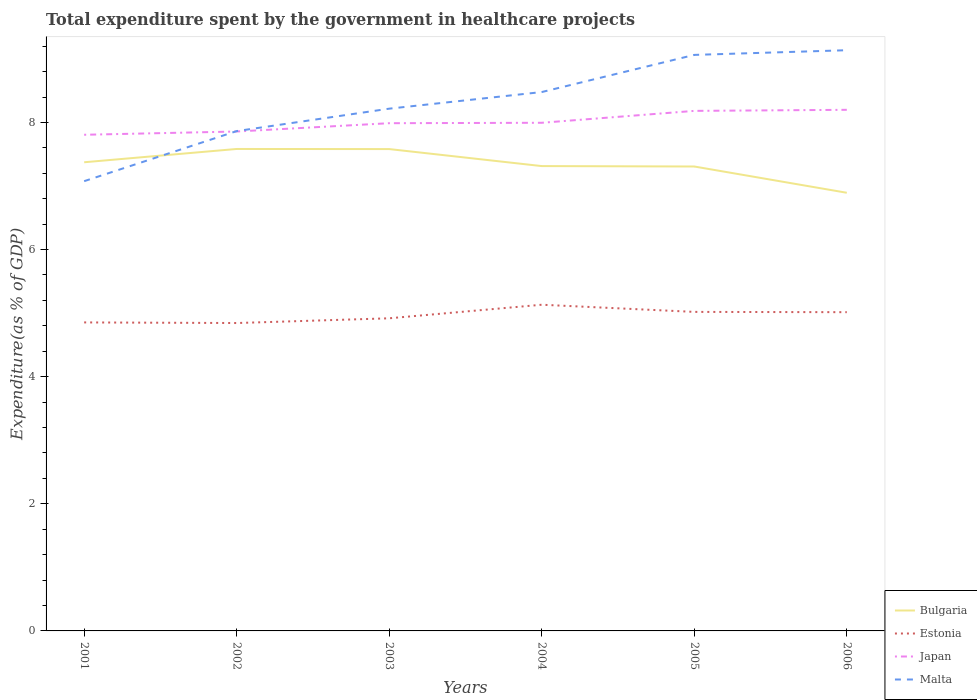How many different coloured lines are there?
Offer a very short reply. 4. Does the line corresponding to Bulgaria intersect with the line corresponding to Malta?
Your response must be concise. Yes. Across all years, what is the maximum total expenditure spent by the government in healthcare projects in Estonia?
Keep it short and to the point. 4.84. In which year was the total expenditure spent by the government in healthcare projects in Japan maximum?
Make the answer very short. 2001. What is the total total expenditure spent by the government in healthcare projects in Estonia in the graph?
Give a very brief answer. 0.01. What is the difference between the highest and the second highest total expenditure spent by the government in healthcare projects in Malta?
Make the answer very short. 2.06. What is the difference between the highest and the lowest total expenditure spent by the government in healthcare projects in Estonia?
Your response must be concise. 3. How many lines are there?
Ensure brevity in your answer.  4. How many legend labels are there?
Offer a very short reply. 4. What is the title of the graph?
Offer a terse response. Total expenditure spent by the government in healthcare projects. What is the label or title of the X-axis?
Offer a very short reply. Years. What is the label or title of the Y-axis?
Your response must be concise. Expenditure(as % of GDP). What is the Expenditure(as % of GDP) in Bulgaria in 2001?
Provide a succinct answer. 7.37. What is the Expenditure(as % of GDP) in Estonia in 2001?
Your response must be concise. 4.85. What is the Expenditure(as % of GDP) of Japan in 2001?
Provide a succinct answer. 7.81. What is the Expenditure(as % of GDP) in Malta in 2001?
Ensure brevity in your answer.  7.08. What is the Expenditure(as % of GDP) in Bulgaria in 2002?
Ensure brevity in your answer.  7.58. What is the Expenditure(as % of GDP) of Estonia in 2002?
Make the answer very short. 4.84. What is the Expenditure(as % of GDP) in Japan in 2002?
Provide a short and direct response. 7.86. What is the Expenditure(as % of GDP) in Malta in 2002?
Your response must be concise. 7.86. What is the Expenditure(as % of GDP) in Bulgaria in 2003?
Ensure brevity in your answer.  7.58. What is the Expenditure(as % of GDP) in Estonia in 2003?
Your answer should be very brief. 4.92. What is the Expenditure(as % of GDP) of Japan in 2003?
Keep it short and to the point. 7.99. What is the Expenditure(as % of GDP) in Malta in 2003?
Provide a short and direct response. 8.22. What is the Expenditure(as % of GDP) in Bulgaria in 2004?
Offer a terse response. 7.31. What is the Expenditure(as % of GDP) in Estonia in 2004?
Your answer should be compact. 5.13. What is the Expenditure(as % of GDP) of Japan in 2004?
Offer a terse response. 7.99. What is the Expenditure(as % of GDP) of Malta in 2004?
Provide a succinct answer. 8.48. What is the Expenditure(as % of GDP) in Bulgaria in 2005?
Your response must be concise. 7.31. What is the Expenditure(as % of GDP) of Estonia in 2005?
Offer a very short reply. 5.02. What is the Expenditure(as % of GDP) in Japan in 2005?
Your answer should be compact. 8.18. What is the Expenditure(as % of GDP) in Malta in 2005?
Offer a very short reply. 9.06. What is the Expenditure(as % of GDP) in Bulgaria in 2006?
Your answer should be compact. 6.89. What is the Expenditure(as % of GDP) in Estonia in 2006?
Your answer should be compact. 5.01. What is the Expenditure(as % of GDP) in Japan in 2006?
Provide a short and direct response. 8.2. What is the Expenditure(as % of GDP) in Malta in 2006?
Your answer should be compact. 9.14. Across all years, what is the maximum Expenditure(as % of GDP) in Bulgaria?
Your answer should be compact. 7.58. Across all years, what is the maximum Expenditure(as % of GDP) of Estonia?
Provide a succinct answer. 5.13. Across all years, what is the maximum Expenditure(as % of GDP) in Japan?
Provide a succinct answer. 8.2. Across all years, what is the maximum Expenditure(as % of GDP) in Malta?
Offer a very short reply. 9.14. Across all years, what is the minimum Expenditure(as % of GDP) in Bulgaria?
Provide a succinct answer. 6.89. Across all years, what is the minimum Expenditure(as % of GDP) in Estonia?
Your response must be concise. 4.84. Across all years, what is the minimum Expenditure(as % of GDP) of Japan?
Ensure brevity in your answer.  7.81. Across all years, what is the minimum Expenditure(as % of GDP) in Malta?
Your answer should be very brief. 7.08. What is the total Expenditure(as % of GDP) in Bulgaria in the graph?
Provide a short and direct response. 44.05. What is the total Expenditure(as % of GDP) in Estonia in the graph?
Offer a very short reply. 29.78. What is the total Expenditure(as % of GDP) of Japan in the graph?
Give a very brief answer. 48.03. What is the total Expenditure(as % of GDP) of Malta in the graph?
Provide a succinct answer. 49.83. What is the difference between the Expenditure(as % of GDP) of Bulgaria in 2001 and that in 2002?
Your answer should be compact. -0.21. What is the difference between the Expenditure(as % of GDP) in Estonia in 2001 and that in 2002?
Make the answer very short. 0.01. What is the difference between the Expenditure(as % of GDP) of Japan in 2001 and that in 2002?
Offer a terse response. -0.05. What is the difference between the Expenditure(as % of GDP) of Malta in 2001 and that in 2002?
Your answer should be compact. -0.79. What is the difference between the Expenditure(as % of GDP) of Bulgaria in 2001 and that in 2003?
Your answer should be very brief. -0.21. What is the difference between the Expenditure(as % of GDP) in Estonia in 2001 and that in 2003?
Ensure brevity in your answer.  -0.06. What is the difference between the Expenditure(as % of GDP) in Japan in 2001 and that in 2003?
Keep it short and to the point. -0.18. What is the difference between the Expenditure(as % of GDP) in Malta in 2001 and that in 2003?
Your answer should be very brief. -1.14. What is the difference between the Expenditure(as % of GDP) of Bulgaria in 2001 and that in 2004?
Keep it short and to the point. 0.06. What is the difference between the Expenditure(as % of GDP) in Estonia in 2001 and that in 2004?
Your answer should be very brief. -0.28. What is the difference between the Expenditure(as % of GDP) in Japan in 2001 and that in 2004?
Make the answer very short. -0.19. What is the difference between the Expenditure(as % of GDP) in Malta in 2001 and that in 2004?
Ensure brevity in your answer.  -1.4. What is the difference between the Expenditure(as % of GDP) of Bulgaria in 2001 and that in 2005?
Offer a very short reply. 0.07. What is the difference between the Expenditure(as % of GDP) in Estonia in 2001 and that in 2005?
Your answer should be very brief. -0.17. What is the difference between the Expenditure(as % of GDP) of Japan in 2001 and that in 2005?
Offer a very short reply. -0.38. What is the difference between the Expenditure(as % of GDP) of Malta in 2001 and that in 2005?
Ensure brevity in your answer.  -1.99. What is the difference between the Expenditure(as % of GDP) of Bulgaria in 2001 and that in 2006?
Provide a short and direct response. 0.48. What is the difference between the Expenditure(as % of GDP) in Estonia in 2001 and that in 2006?
Offer a terse response. -0.16. What is the difference between the Expenditure(as % of GDP) of Japan in 2001 and that in 2006?
Provide a short and direct response. -0.39. What is the difference between the Expenditure(as % of GDP) of Malta in 2001 and that in 2006?
Give a very brief answer. -2.06. What is the difference between the Expenditure(as % of GDP) in Bulgaria in 2002 and that in 2003?
Offer a terse response. 0. What is the difference between the Expenditure(as % of GDP) of Estonia in 2002 and that in 2003?
Offer a very short reply. -0.07. What is the difference between the Expenditure(as % of GDP) in Japan in 2002 and that in 2003?
Offer a terse response. -0.13. What is the difference between the Expenditure(as % of GDP) of Malta in 2002 and that in 2003?
Provide a short and direct response. -0.35. What is the difference between the Expenditure(as % of GDP) of Bulgaria in 2002 and that in 2004?
Offer a very short reply. 0.27. What is the difference between the Expenditure(as % of GDP) of Estonia in 2002 and that in 2004?
Offer a terse response. -0.29. What is the difference between the Expenditure(as % of GDP) in Japan in 2002 and that in 2004?
Your answer should be compact. -0.14. What is the difference between the Expenditure(as % of GDP) of Malta in 2002 and that in 2004?
Your answer should be very brief. -0.61. What is the difference between the Expenditure(as % of GDP) of Bulgaria in 2002 and that in 2005?
Offer a very short reply. 0.28. What is the difference between the Expenditure(as % of GDP) in Estonia in 2002 and that in 2005?
Ensure brevity in your answer.  -0.18. What is the difference between the Expenditure(as % of GDP) of Japan in 2002 and that in 2005?
Provide a short and direct response. -0.32. What is the difference between the Expenditure(as % of GDP) in Malta in 2002 and that in 2005?
Keep it short and to the point. -1.2. What is the difference between the Expenditure(as % of GDP) in Bulgaria in 2002 and that in 2006?
Offer a very short reply. 0.69. What is the difference between the Expenditure(as % of GDP) in Estonia in 2002 and that in 2006?
Your answer should be very brief. -0.17. What is the difference between the Expenditure(as % of GDP) of Japan in 2002 and that in 2006?
Offer a very short reply. -0.34. What is the difference between the Expenditure(as % of GDP) of Malta in 2002 and that in 2006?
Ensure brevity in your answer.  -1.27. What is the difference between the Expenditure(as % of GDP) of Bulgaria in 2003 and that in 2004?
Offer a very short reply. 0.27. What is the difference between the Expenditure(as % of GDP) in Estonia in 2003 and that in 2004?
Ensure brevity in your answer.  -0.21. What is the difference between the Expenditure(as % of GDP) in Japan in 2003 and that in 2004?
Offer a terse response. -0.01. What is the difference between the Expenditure(as % of GDP) in Malta in 2003 and that in 2004?
Give a very brief answer. -0.26. What is the difference between the Expenditure(as % of GDP) of Bulgaria in 2003 and that in 2005?
Give a very brief answer. 0.27. What is the difference between the Expenditure(as % of GDP) of Estonia in 2003 and that in 2005?
Ensure brevity in your answer.  -0.1. What is the difference between the Expenditure(as % of GDP) in Japan in 2003 and that in 2005?
Provide a succinct answer. -0.19. What is the difference between the Expenditure(as % of GDP) of Malta in 2003 and that in 2005?
Provide a succinct answer. -0.85. What is the difference between the Expenditure(as % of GDP) of Bulgaria in 2003 and that in 2006?
Offer a very short reply. 0.69. What is the difference between the Expenditure(as % of GDP) of Estonia in 2003 and that in 2006?
Make the answer very short. -0.1. What is the difference between the Expenditure(as % of GDP) of Japan in 2003 and that in 2006?
Provide a short and direct response. -0.21. What is the difference between the Expenditure(as % of GDP) of Malta in 2003 and that in 2006?
Offer a terse response. -0.92. What is the difference between the Expenditure(as % of GDP) of Bulgaria in 2004 and that in 2005?
Offer a very short reply. 0.01. What is the difference between the Expenditure(as % of GDP) in Estonia in 2004 and that in 2005?
Your answer should be very brief. 0.11. What is the difference between the Expenditure(as % of GDP) in Japan in 2004 and that in 2005?
Your answer should be compact. -0.19. What is the difference between the Expenditure(as % of GDP) in Malta in 2004 and that in 2005?
Your answer should be very brief. -0.58. What is the difference between the Expenditure(as % of GDP) of Bulgaria in 2004 and that in 2006?
Your answer should be compact. 0.42. What is the difference between the Expenditure(as % of GDP) in Estonia in 2004 and that in 2006?
Offer a very short reply. 0.12. What is the difference between the Expenditure(as % of GDP) in Japan in 2004 and that in 2006?
Offer a terse response. -0.2. What is the difference between the Expenditure(as % of GDP) of Malta in 2004 and that in 2006?
Your answer should be compact. -0.66. What is the difference between the Expenditure(as % of GDP) in Bulgaria in 2005 and that in 2006?
Keep it short and to the point. 0.41. What is the difference between the Expenditure(as % of GDP) of Estonia in 2005 and that in 2006?
Offer a terse response. 0. What is the difference between the Expenditure(as % of GDP) of Japan in 2005 and that in 2006?
Offer a terse response. -0.02. What is the difference between the Expenditure(as % of GDP) in Malta in 2005 and that in 2006?
Your answer should be compact. -0.07. What is the difference between the Expenditure(as % of GDP) of Bulgaria in 2001 and the Expenditure(as % of GDP) of Estonia in 2002?
Provide a short and direct response. 2.53. What is the difference between the Expenditure(as % of GDP) of Bulgaria in 2001 and the Expenditure(as % of GDP) of Japan in 2002?
Provide a succinct answer. -0.48. What is the difference between the Expenditure(as % of GDP) of Bulgaria in 2001 and the Expenditure(as % of GDP) of Malta in 2002?
Provide a succinct answer. -0.49. What is the difference between the Expenditure(as % of GDP) in Estonia in 2001 and the Expenditure(as % of GDP) in Japan in 2002?
Provide a succinct answer. -3. What is the difference between the Expenditure(as % of GDP) of Estonia in 2001 and the Expenditure(as % of GDP) of Malta in 2002?
Give a very brief answer. -3.01. What is the difference between the Expenditure(as % of GDP) in Japan in 2001 and the Expenditure(as % of GDP) in Malta in 2002?
Your response must be concise. -0.06. What is the difference between the Expenditure(as % of GDP) in Bulgaria in 2001 and the Expenditure(as % of GDP) in Estonia in 2003?
Your answer should be compact. 2.45. What is the difference between the Expenditure(as % of GDP) in Bulgaria in 2001 and the Expenditure(as % of GDP) in Japan in 2003?
Offer a very short reply. -0.61. What is the difference between the Expenditure(as % of GDP) of Bulgaria in 2001 and the Expenditure(as % of GDP) of Malta in 2003?
Provide a short and direct response. -0.84. What is the difference between the Expenditure(as % of GDP) in Estonia in 2001 and the Expenditure(as % of GDP) in Japan in 2003?
Provide a succinct answer. -3.13. What is the difference between the Expenditure(as % of GDP) of Estonia in 2001 and the Expenditure(as % of GDP) of Malta in 2003?
Provide a succinct answer. -3.36. What is the difference between the Expenditure(as % of GDP) of Japan in 2001 and the Expenditure(as % of GDP) of Malta in 2003?
Your answer should be very brief. -0.41. What is the difference between the Expenditure(as % of GDP) of Bulgaria in 2001 and the Expenditure(as % of GDP) of Estonia in 2004?
Give a very brief answer. 2.24. What is the difference between the Expenditure(as % of GDP) in Bulgaria in 2001 and the Expenditure(as % of GDP) in Japan in 2004?
Your answer should be compact. -0.62. What is the difference between the Expenditure(as % of GDP) in Bulgaria in 2001 and the Expenditure(as % of GDP) in Malta in 2004?
Offer a terse response. -1.1. What is the difference between the Expenditure(as % of GDP) of Estonia in 2001 and the Expenditure(as % of GDP) of Japan in 2004?
Give a very brief answer. -3.14. What is the difference between the Expenditure(as % of GDP) in Estonia in 2001 and the Expenditure(as % of GDP) in Malta in 2004?
Your answer should be very brief. -3.62. What is the difference between the Expenditure(as % of GDP) of Japan in 2001 and the Expenditure(as % of GDP) of Malta in 2004?
Provide a succinct answer. -0.67. What is the difference between the Expenditure(as % of GDP) in Bulgaria in 2001 and the Expenditure(as % of GDP) in Estonia in 2005?
Offer a very short reply. 2.35. What is the difference between the Expenditure(as % of GDP) in Bulgaria in 2001 and the Expenditure(as % of GDP) in Japan in 2005?
Provide a short and direct response. -0.81. What is the difference between the Expenditure(as % of GDP) of Bulgaria in 2001 and the Expenditure(as % of GDP) of Malta in 2005?
Ensure brevity in your answer.  -1.69. What is the difference between the Expenditure(as % of GDP) of Estonia in 2001 and the Expenditure(as % of GDP) of Japan in 2005?
Your answer should be compact. -3.33. What is the difference between the Expenditure(as % of GDP) of Estonia in 2001 and the Expenditure(as % of GDP) of Malta in 2005?
Provide a succinct answer. -4.21. What is the difference between the Expenditure(as % of GDP) of Japan in 2001 and the Expenditure(as % of GDP) of Malta in 2005?
Make the answer very short. -1.26. What is the difference between the Expenditure(as % of GDP) of Bulgaria in 2001 and the Expenditure(as % of GDP) of Estonia in 2006?
Offer a terse response. 2.36. What is the difference between the Expenditure(as % of GDP) in Bulgaria in 2001 and the Expenditure(as % of GDP) in Japan in 2006?
Ensure brevity in your answer.  -0.82. What is the difference between the Expenditure(as % of GDP) of Bulgaria in 2001 and the Expenditure(as % of GDP) of Malta in 2006?
Provide a succinct answer. -1.76. What is the difference between the Expenditure(as % of GDP) of Estonia in 2001 and the Expenditure(as % of GDP) of Japan in 2006?
Provide a short and direct response. -3.34. What is the difference between the Expenditure(as % of GDP) of Estonia in 2001 and the Expenditure(as % of GDP) of Malta in 2006?
Provide a short and direct response. -4.28. What is the difference between the Expenditure(as % of GDP) in Japan in 2001 and the Expenditure(as % of GDP) in Malta in 2006?
Your answer should be very brief. -1.33. What is the difference between the Expenditure(as % of GDP) in Bulgaria in 2002 and the Expenditure(as % of GDP) in Estonia in 2003?
Offer a terse response. 2.66. What is the difference between the Expenditure(as % of GDP) in Bulgaria in 2002 and the Expenditure(as % of GDP) in Japan in 2003?
Your response must be concise. -0.41. What is the difference between the Expenditure(as % of GDP) in Bulgaria in 2002 and the Expenditure(as % of GDP) in Malta in 2003?
Give a very brief answer. -0.63. What is the difference between the Expenditure(as % of GDP) of Estonia in 2002 and the Expenditure(as % of GDP) of Japan in 2003?
Make the answer very short. -3.14. What is the difference between the Expenditure(as % of GDP) of Estonia in 2002 and the Expenditure(as % of GDP) of Malta in 2003?
Your response must be concise. -3.37. What is the difference between the Expenditure(as % of GDP) of Japan in 2002 and the Expenditure(as % of GDP) of Malta in 2003?
Offer a terse response. -0.36. What is the difference between the Expenditure(as % of GDP) in Bulgaria in 2002 and the Expenditure(as % of GDP) in Estonia in 2004?
Keep it short and to the point. 2.45. What is the difference between the Expenditure(as % of GDP) of Bulgaria in 2002 and the Expenditure(as % of GDP) of Japan in 2004?
Keep it short and to the point. -0.41. What is the difference between the Expenditure(as % of GDP) in Bulgaria in 2002 and the Expenditure(as % of GDP) in Malta in 2004?
Offer a terse response. -0.9. What is the difference between the Expenditure(as % of GDP) of Estonia in 2002 and the Expenditure(as % of GDP) of Japan in 2004?
Provide a short and direct response. -3.15. What is the difference between the Expenditure(as % of GDP) in Estonia in 2002 and the Expenditure(as % of GDP) in Malta in 2004?
Offer a terse response. -3.63. What is the difference between the Expenditure(as % of GDP) in Japan in 2002 and the Expenditure(as % of GDP) in Malta in 2004?
Offer a very short reply. -0.62. What is the difference between the Expenditure(as % of GDP) of Bulgaria in 2002 and the Expenditure(as % of GDP) of Estonia in 2005?
Your answer should be compact. 2.56. What is the difference between the Expenditure(as % of GDP) in Bulgaria in 2002 and the Expenditure(as % of GDP) in Japan in 2005?
Offer a terse response. -0.6. What is the difference between the Expenditure(as % of GDP) in Bulgaria in 2002 and the Expenditure(as % of GDP) in Malta in 2005?
Your answer should be very brief. -1.48. What is the difference between the Expenditure(as % of GDP) of Estonia in 2002 and the Expenditure(as % of GDP) of Japan in 2005?
Your response must be concise. -3.34. What is the difference between the Expenditure(as % of GDP) of Estonia in 2002 and the Expenditure(as % of GDP) of Malta in 2005?
Keep it short and to the point. -4.22. What is the difference between the Expenditure(as % of GDP) in Japan in 2002 and the Expenditure(as % of GDP) in Malta in 2005?
Your answer should be compact. -1.21. What is the difference between the Expenditure(as % of GDP) in Bulgaria in 2002 and the Expenditure(as % of GDP) in Estonia in 2006?
Give a very brief answer. 2.57. What is the difference between the Expenditure(as % of GDP) of Bulgaria in 2002 and the Expenditure(as % of GDP) of Japan in 2006?
Offer a very short reply. -0.62. What is the difference between the Expenditure(as % of GDP) of Bulgaria in 2002 and the Expenditure(as % of GDP) of Malta in 2006?
Your response must be concise. -1.55. What is the difference between the Expenditure(as % of GDP) in Estonia in 2002 and the Expenditure(as % of GDP) in Japan in 2006?
Your answer should be compact. -3.35. What is the difference between the Expenditure(as % of GDP) in Estonia in 2002 and the Expenditure(as % of GDP) in Malta in 2006?
Offer a very short reply. -4.29. What is the difference between the Expenditure(as % of GDP) of Japan in 2002 and the Expenditure(as % of GDP) of Malta in 2006?
Give a very brief answer. -1.28. What is the difference between the Expenditure(as % of GDP) in Bulgaria in 2003 and the Expenditure(as % of GDP) in Estonia in 2004?
Offer a very short reply. 2.45. What is the difference between the Expenditure(as % of GDP) in Bulgaria in 2003 and the Expenditure(as % of GDP) in Japan in 2004?
Make the answer very short. -0.41. What is the difference between the Expenditure(as % of GDP) of Bulgaria in 2003 and the Expenditure(as % of GDP) of Malta in 2004?
Your answer should be very brief. -0.9. What is the difference between the Expenditure(as % of GDP) in Estonia in 2003 and the Expenditure(as % of GDP) in Japan in 2004?
Offer a very short reply. -3.08. What is the difference between the Expenditure(as % of GDP) of Estonia in 2003 and the Expenditure(as % of GDP) of Malta in 2004?
Provide a short and direct response. -3.56. What is the difference between the Expenditure(as % of GDP) in Japan in 2003 and the Expenditure(as % of GDP) in Malta in 2004?
Your response must be concise. -0.49. What is the difference between the Expenditure(as % of GDP) of Bulgaria in 2003 and the Expenditure(as % of GDP) of Estonia in 2005?
Your response must be concise. 2.56. What is the difference between the Expenditure(as % of GDP) of Bulgaria in 2003 and the Expenditure(as % of GDP) of Japan in 2005?
Ensure brevity in your answer.  -0.6. What is the difference between the Expenditure(as % of GDP) in Bulgaria in 2003 and the Expenditure(as % of GDP) in Malta in 2005?
Ensure brevity in your answer.  -1.48. What is the difference between the Expenditure(as % of GDP) of Estonia in 2003 and the Expenditure(as % of GDP) of Japan in 2005?
Give a very brief answer. -3.26. What is the difference between the Expenditure(as % of GDP) of Estonia in 2003 and the Expenditure(as % of GDP) of Malta in 2005?
Offer a terse response. -4.14. What is the difference between the Expenditure(as % of GDP) of Japan in 2003 and the Expenditure(as % of GDP) of Malta in 2005?
Ensure brevity in your answer.  -1.07. What is the difference between the Expenditure(as % of GDP) of Bulgaria in 2003 and the Expenditure(as % of GDP) of Estonia in 2006?
Ensure brevity in your answer.  2.57. What is the difference between the Expenditure(as % of GDP) in Bulgaria in 2003 and the Expenditure(as % of GDP) in Japan in 2006?
Give a very brief answer. -0.62. What is the difference between the Expenditure(as % of GDP) of Bulgaria in 2003 and the Expenditure(as % of GDP) of Malta in 2006?
Offer a very short reply. -1.56. What is the difference between the Expenditure(as % of GDP) in Estonia in 2003 and the Expenditure(as % of GDP) in Japan in 2006?
Give a very brief answer. -3.28. What is the difference between the Expenditure(as % of GDP) in Estonia in 2003 and the Expenditure(as % of GDP) in Malta in 2006?
Provide a short and direct response. -4.22. What is the difference between the Expenditure(as % of GDP) in Japan in 2003 and the Expenditure(as % of GDP) in Malta in 2006?
Provide a short and direct response. -1.15. What is the difference between the Expenditure(as % of GDP) in Bulgaria in 2004 and the Expenditure(as % of GDP) in Estonia in 2005?
Your answer should be very brief. 2.29. What is the difference between the Expenditure(as % of GDP) of Bulgaria in 2004 and the Expenditure(as % of GDP) of Japan in 2005?
Offer a terse response. -0.87. What is the difference between the Expenditure(as % of GDP) of Bulgaria in 2004 and the Expenditure(as % of GDP) of Malta in 2005?
Provide a short and direct response. -1.75. What is the difference between the Expenditure(as % of GDP) of Estonia in 2004 and the Expenditure(as % of GDP) of Japan in 2005?
Provide a short and direct response. -3.05. What is the difference between the Expenditure(as % of GDP) in Estonia in 2004 and the Expenditure(as % of GDP) in Malta in 2005?
Your answer should be very brief. -3.93. What is the difference between the Expenditure(as % of GDP) in Japan in 2004 and the Expenditure(as % of GDP) in Malta in 2005?
Give a very brief answer. -1.07. What is the difference between the Expenditure(as % of GDP) of Bulgaria in 2004 and the Expenditure(as % of GDP) of Estonia in 2006?
Offer a terse response. 2.3. What is the difference between the Expenditure(as % of GDP) of Bulgaria in 2004 and the Expenditure(as % of GDP) of Japan in 2006?
Provide a succinct answer. -0.89. What is the difference between the Expenditure(as % of GDP) in Bulgaria in 2004 and the Expenditure(as % of GDP) in Malta in 2006?
Provide a succinct answer. -1.82. What is the difference between the Expenditure(as % of GDP) in Estonia in 2004 and the Expenditure(as % of GDP) in Japan in 2006?
Give a very brief answer. -3.07. What is the difference between the Expenditure(as % of GDP) of Estonia in 2004 and the Expenditure(as % of GDP) of Malta in 2006?
Keep it short and to the point. -4. What is the difference between the Expenditure(as % of GDP) of Japan in 2004 and the Expenditure(as % of GDP) of Malta in 2006?
Your answer should be very brief. -1.14. What is the difference between the Expenditure(as % of GDP) in Bulgaria in 2005 and the Expenditure(as % of GDP) in Estonia in 2006?
Your answer should be compact. 2.29. What is the difference between the Expenditure(as % of GDP) of Bulgaria in 2005 and the Expenditure(as % of GDP) of Japan in 2006?
Offer a terse response. -0.89. What is the difference between the Expenditure(as % of GDP) in Bulgaria in 2005 and the Expenditure(as % of GDP) in Malta in 2006?
Your answer should be very brief. -1.83. What is the difference between the Expenditure(as % of GDP) in Estonia in 2005 and the Expenditure(as % of GDP) in Japan in 2006?
Provide a succinct answer. -3.18. What is the difference between the Expenditure(as % of GDP) in Estonia in 2005 and the Expenditure(as % of GDP) in Malta in 2006?
Offer a terse response. -4.12. What is the difference between the Expenditure(as % of GDP) in Japan in 2005 and the Expenditure(as % of GDP) in Malta in 2006?
Your answer should be compact. -0.95. What is the average Expenditure(as % of GDP) of Bulgaria per year?
Provide a short and direct response. 7.34. What is the average Expenditure(as % of GDP) in Estonia per year?
Offer a very short reply. 4.96. What is the average Expenditure(as % of GDP) in Japan per year?
Offer a very short reply. 8. What is the average Expenditure(as % of GDP) of Malta per year?
Give a very brief answer. 8.31. In the year 2001, what is the difference between the Expenditure(as % of GDP) in Bulgaria and Expenditure(as % of GDP) in Estonia?
Offer a very short reply. 2.52. In the year 2001, what is the difference between the Expenditure(as % of GDP) of Bulgaria and Expenditure(as % of GDP) of Japan?
Offer a very short reply. -0.43. In the year 2001, what is the difference between the Expenditure(as % of GDP) in Bulgaria and Expenditure(as % of GDP) in Malta?
Your response must be concise. 0.3. In the year 2001, what is the difference between the Expenditure(as % of GDP) of Estonia and Expenditure(as % of GDP) of Japan?
Make the answer very short. -2.95. In the year 2001, what is the difference between the Expenditure(as % of GDP) of Estonia and Expenditure(as % of GDP) of Malta?
Provide a succinct answer. -2.22. In the year 2001, what is the difference between the Expenditure(as % of GDP) in Japan and Expenditure(as % of GDP) in Malta?
Offer a terse response. 0.73. In the year 2002, what is the difference between the Expenditure(as % of GDP) of Bulgaria and Expenditure(as % of GDP) of Estonia?
Your answer should be compact. 2.74. In the year 2002, what is the difference between the Expenditure(as % of GDP) of Bulgaria and Expenditure(as % of GDP) of Japan?
Your answer should be compact. -0.27. In the year 2002, what is the difference between the Expenditure(as % of GDP) in Bulgaria and Expenditure(as % of GDP) in Malta?
Offer a very short reply. -0.28. In the year 2002, what is the difference between the Expenditure(as % of GDP) of Estonia and Expenditure(as % of GDP) of Japan?
Provide a short and direct response. -3.01. In the year 2002, what is the difference between the Expenditure(as % of GDP) of Estonia and Expenditure(as % of GDP) of Malta?
Your response must be concise. -3.02. In the year 2002, what is the difference between the Expenditure(as % of GDP) of Japan and Expenditure(as % of GDP) of Malta?
Ensure brevity in your answer.  -0.01. In the year 2003, what is the difference between the Expenditure(as % of GDP) of Bulgaria and Expenditure(as % of GDP) of Estonia?
Your answer should be very brief. 2.66. In the year 2003, what is the difference between the Expenditure(as % of GDP) in Bulgaria and Expenditure(as % of GDP) in Japan?
Keep it short and to the point. -0.41. In the year 2003, what is the difference between the Expenditure(as % of GDP) of Bulgaria and Expenditure(as % of GDP) of Malta?
Give a very brief answer. -0.64. In the year 2003, what is the difference between the Expenditure(as % of GDP) in Estonia and Expenditure(as % of GDP) in Japan?
Your response must be concise. -3.07. In the year 2003, what is the difference between the Expenditure(as % of GDP) of Estonia and Expenditure(as % of GDP) of Malta?
Ensure brevity in your answer.  -3.3. In the year 2003, what is the difference between the Expenditure(as % of GDP) of Japan and Expenditure(as % of GDP) of Malta?
Provide a succinct answer. -0.23. In the year 2004, what is the difference between the Expenditure(as % of GDP) in Bulgaria and Expenditure(as % of GDP) in Estonia?
Ensure brevity in your answer.  2.18. In the year 2004, what is the difference between the Expenditure(as % of GDP) of Bulgaria and Expenditure(as % of GDP) of Japan?
Make the answer very short. -0.68. In the year 2004, what is the difference between the Expenditure(as % of GDP) in Bulgaria and Expenditure(as % of GDP) in Malta?
Offer a terse response. -1.16. In the year 2004, what is the difference between the Expenditure(as % of GDP) in Estonia and Expenditure(as % of GDP) in Japan?
Your answer should be compact. -2.86. In the year 2004, what is the difference between the Expenditure(as % of GDP) in Estonia and Expenditure(as % of GDP) in Malta?
Your answer should be compact. -3.35. In the year 2004, what is the difference between the Expenditure(as % of GDP) in Japan and Expenditure(as % of GDP) in Malta?
Your answer should be compact. -0.48. In the year 2005, what is the difference between the Expenditure(as % of GDP) of Bulgaria and Expenditure(as % of GDP) of Estonia?
Your response must be concise. 2.29. In the year 2005, what is the difference between the Expenditure(as % of GDP) of Bulgaria and Expenditure(as % of GDP) of Japan?
Offer a very short reply. -0.88. In the year 2005, what is the difference between the Expenditure(as % of GDP) of Bulgaria and Expenditure(as % of GDP) of Malta?
Your answer should be compact. -1.76. In the year 2005, what is the difference between the Expenditure(as % of GDP) in Estonia and Expenditure(as % of GDP) in Japan?
Provide a succinct answer. -3.16. In the year 2005, what is the difference between the Expenditure(as % of GDP) of Estonia and Expenditure(as % of GDP) of Malta?
Make the answer very short. -4.04. In the year 2005, what is the difference between the Expenditure(as % of GDP) of Japan and Expenditure(as % of GDP) of Malta?
Your answer should be compact. -0.88. In the year 2006, what is the difference between the Expenditure(as % of GDP) in Bulgaria and Expenditure(as % of GDP) in Estonia?
Ensure brevity in your answer.  1.88. In the year 2006, what is the difference between the Expenditure(as % of GDP) of Bulgaria and Expenditure(as % of GDP) of Japan?
Keep it short and to the point. -1.3. In the year 2006, what is the difference between the Expenditure(as % of GDP) of Bulgaria and Expenditure(as % of GDP) of Malta?
Your answer should be very brief. -2.24. In the year 2006, what is the difference between the Expenditure(as % of GDP) in Estonia and Expenditure(as % of GDP) in Japan?
Your answer should be very brief. -3.18. In the year 2006, what is the difference between the Expenditure(as % of GDP) of Estonia and Expenditure(as % of GDP) of Malta?
Your answer should be compact. -4.12. In the year 2006, what is the difference between the Expenditure(as % of GDP) of Japan and Expenditure(as % of GDP) of Malta?
Your answer should be compact. -0.94. What is the ratio of the Expenditure(as % of GDP) in Bulgaria in 2001 to that in 2002?
Provide a succinct answer. 0.97. What is the ratio of the Expenditure(as % of GDP) in Japan in 2001 to that in 2002?
Keep it short and to the point. 0.99. What is the ratio of the Expenditure(as % of GDP) of Malta in 2001 to that in 2002?
Give a very brief answer. 0.9. What is the ratio of the Expenditure(as % of GDP) of Bulgaria in 2001 to that in 2003?
Give a very brief answer. 0.97. What is the ratio of the Expenditure(as % of GDP) of Japan in 2001 to that in 2003?
Offer a very short reply. 0.98. What is the ratio of the Expenditure(as % of GDP) in Malta in 2001 to that in 2003?
Your response must be concise. 0.86. What is the ratio of the Expenditure(as % of GDP) of Bulgaria in 2001 to that in 2004?
Your answer should be compact. 1.01. What is the ratio of the Expenditure(as % of GDP) in Estonia in 2001 to that in 2004?
Offer a very short reply. 0.95. What is the ratio of the Expenditure(as % of GDP) in Japan in 2001 to that in 2004?
Provide a succinct answer. 0.98. What is the ratio of the Expenditure(as % of GDP) of Malta in 2001 to that in 2004?
Keep it short and to the point. 0.83. What is the ratio of the Expenditure(as % of GDP) of Bulgaria in 2001 to that in 2005?
Your answer should be compact. 1.01. What is the ratio of the Expenditure(as % of GDP) of Estonia in 2001 to that in 2005?
Give a very brief answer. 0.97. What is the ratio of the Expenditure(as % of GDP) of Japan in 2001 to that in 2005?
Your response must be concise. 0.95. What is the ratio of the Expenditure(as % of GDP) of Malta in 2001 to that in 2005?
Offer a terse response. 0.78. What is the ratio of the Expenditure(as % of GDP) in Bulgaria in 2001 to that in 2006?
Keep it short and to the point. 1.07. What is the ratio of the Expenditure(as % of GDP) in Estonia in 2001 to that in 2006?
Offer a very short reply. 0.97. What is the ratio of the Expenditure(as % of GDP) of Japan in 2001 to that in 2006?
Your answer should be compact. 0.95. What is the ratio of the Expenditure(as % of GDP) of Malta in 2001 to that in 2006?
Offer a very short reply. 0.77. What is the ratio of the Expenditure(as % of GDP) in Bulgaria in 2002 to that in 2003?
Make the answer very short. 1. What is the ratio of the Expenditure(as % of GDP) of Japan in 2002 to that in 2003?
Your response must be concise. 0.98. What is the ratio of the Expenditure(as % of GDP) of Malta in 2002 to that in 2003?
Provide a succinct answer. 0.96. What is the ratio of the Expenditure(as % of GDP) of Bulgaria in 2002 to that in 2004?
Provide a succinct answer. 1.04. What is the ratio of the Expenditure(as % of GDP) of Estonia in 2002 to that in 2004?
Give a very brief answer. 0.94. What is the ratio of the Expenditure(as % of GDP) in Japan in 2002 to that in 2004?
Your response must be concise. 0.98. What is the ratio of the Expenditure(as % of GDP) in Malta in 2002 to that in 2004?
Offer a very short reply. 0.93. What is the ratio of the Expenditure(as % of GDP) in Bulgaria in 2002 to that in 2005?
Give a very brief answer. 1.04. What is the ratio of the Expenditure(as % of GDP) of Estonia in 2002 to that in 2005?
Provide a succinct answer. 0.97. What is the ratio of the Expenditure(as % of GDP) of Japan in 2002 to that in 2005?
Make the answer very short. 0.96. What is the ratio of the Expenditure(as % of GDP) of Malta in 2002 to that in 2005?
Give a very brief answer. 0.87. What is the ratio of the Expenditure(as % of GDP) of Estonia in 2002 to that in 2006?
Provide a succinct answer. 0.97. What is the ratio of the Expenditure(as % of GDP) in Japan in 2002 to that in 2006?
Give a very brief answer. 0.96. What is the ratio of the Expenditure(as % of GDP) in Malta in 2002 to that in 2006?
Offer a terse response. 0.86. What is the ratio of the Expenditure(as % of GDP) of Bulgaria in 2003 to that in 2004?
Offer a very short reply. 1.04. What is the ratio of the Expenditure(as % of GDP) of Estonia in 2003 to that in 2004?
Your answer should be compact. 0.96. What is the ratio of the Expenditure(as % of GDP) in Japan in 2003 to that in 2004?
Offer a terse response. 1. What is the ratio of the Expenditure(as % of GDP) of Malta in 2003 to that in 2004?
Ensure brevity in your answer.  0.97. What is the ratio of the Expenditure(as % of GDP) of Bulgaria in 2003 to that in 2005?
Keep it short and to the point. 1.04. What is the ratio of the Expenditure(as % of GDP) of Estonia in 2003 to that in 2005?
Your answer should be compact. 0.98. What is the ratio of the Expenditure(as % of GDP) in Japan in 2003 to that in 2005?
Provide a succinct answer. 0.98. What is the ratio of the Expenditure(as % of GDP) of Malta in 2003 to that in 2005?
Offer a very short reply. 0.91. What is the ratio of the Expenditure(as % of GDP) of Bulgaria in 2003 to that in 2006?
Make the answer very short. 1.1. What is the ratio of the Expenditure(as % of GDP) in Estonia in 2003 to that in 2006?
Provide a short and direct response. 0.98. What is the ratio of the Expenditure(as % of GDP) in Japan in 2003 to that in 2006?
Offer a terse response. 0.97. What is the ratio of the Expenditure(as % of GDP) in Malta in 2003 to that in 2006?
Give a very brief answer. 0.9. What is the ratio of the Expenditure(as % of GDP) in Bulgaria in 2004 to that in 2005?
Your answer should be compact. 1. What is the ratio of the Expenditure(as % of GDP) in Estonia in 2004 to that in 2005?
Provide a short and direct response. 1.02. What is the ratio of the Expenditure(as % of GDP) of Japan in 2004 to that in 2005?
Provide a succinct answer. 0.98. What is the ratio of the Expenditure(as % of GDP) of Malta in 2004 to that in 2005?
Give a very brief answer. 0.94. What is the ratio of the Expenditure(as % of GDP) of Bulgaria in 2004 to that in 2006?
Provide a succinct answer. 1.06. What is the ratio of the Expenditure(as % of GDP) of Estonia in 2004 to that in 2006?
Give a very brief answer. 1.02. What is the ratio of the Expenditure(as % of GDP) of Japan in 2004 to that in 2006?
Your answer should be compact. 0.98. What is the ratio of the Expenditure(as % of GDP) in Malta in 2004 to that in 2006?
Your answer should be very brief. 0.93. What is the ratio of the Expenditure(as % of GDP) of Bulgaria in 2005 to that in 2006?
Provide a short and direct response. 1.06. What is the ratio of the Expenditure(as % of GDP) in Japan in 2005 to that in 2006?
Your response must be concise. 1. What is the difference between the highest and the second highest Expenditure(as % of GDP) of Bulgaria?
Your answer should be very brief. 0. What is the difference between the highest and the second highest Expenditure(as % of GDP) of Estonia?
Offer a very short reply. 0.11. What is the difference between the highest and the second highest Expenditure(as % of GDP) of Japan?
Keep it short and to the point. 0.02. What is the difference between the highest and the second highest Expenditure(as % of GDP) in Malta?
Offer a terse response. 0.07. What is the difference between the highest and the lowest Expenditure(as % of GDP) in Bulgaria?
Provide a succinct answer. 0.69. What is the difference between the highest and the lowest Expenditure(as % of GDP) in Estonia?
Keep it short and to the point. 0.29. What is the difference between the highest and the lowest Expenditure(as % of GDP) in Japan?
Offer a very short reply. 0.39. What is the difference between the highest and the lowest Expenditure(as % of GDP) of Malta?
Provide a short and direct response. 2.06. 